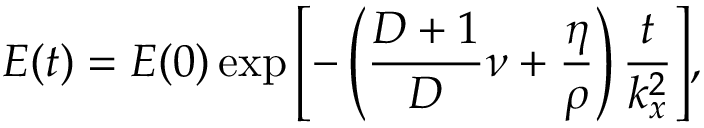<formula> <loc_0><loc_0><loc_500><loc_500>E ( t ) = E ( 0 ) \exp { \left [ - \left ( \frac { D + 1 } { D } \nu + \frac { \eta } { \rho } \right ) \frac { t } { k _ { x } ^ { 2 } } \right ] } ,</formula> 